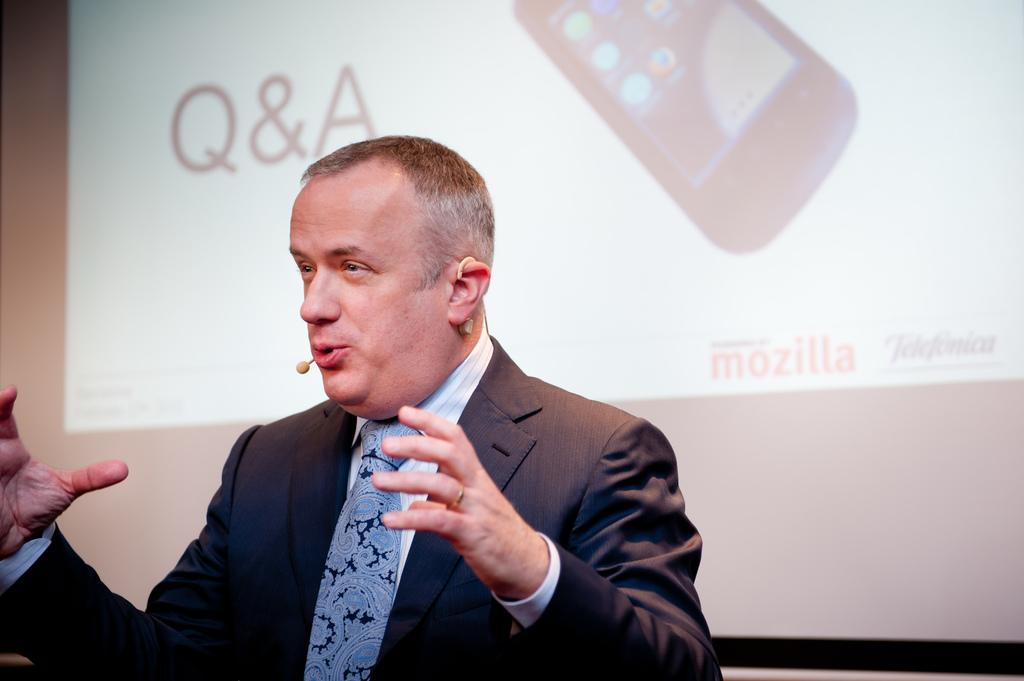What is present in the image? There is a person in the image. Can you describe the person's appearance? The person is wearing clothes. What can be seen in the background of the image? There is a screen in the background of the image. What type of land can be seen in the image? There is no land visible in the image; it features a person and a screen in the background. What kind of beam is supporting the person in the image? There is no beam present in the image; the person is standing on their own. 